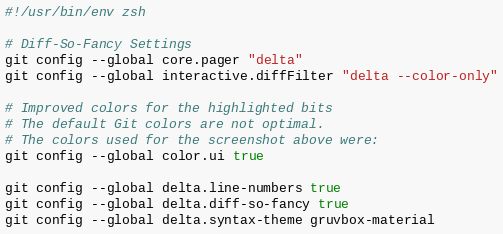Convert code to text. <code><loc_0><loc_0><loc_500><loc_500><_Bash_>#!/usr/bin/env zsh

# Diff-So-Fancy Settings
git config --global core.pager "delta"
git config --global interactive.diffFilter "delta --color-only"

# Improved colors for the highlighted bits
# The default Git colors are not optimal.
# The colors used for the screenshot above were:
git config --global color.ui true

git config --global delta.line-numbers true
git config --global delta.diff-so-fancy true
git config --global delta.syntax-theme gruvbox-material
</code> 